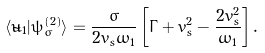Convert formula to latex. <formula><loc_0><loc_0><loc_500><loc_500>\langle \tilde { u } _ { 1 } | \psi _ { \sigma } ^ { ( 2 ) } \rangle = \frac { \sigma } { 2 v _ { s } \omega _ { 1 } } \left [ \Gamma + v _ { s } ^ { 2 } - \frac { 2 v _ { s } ^ { 2 } } { \omega _ { 1 } } \right ] .</formula> 